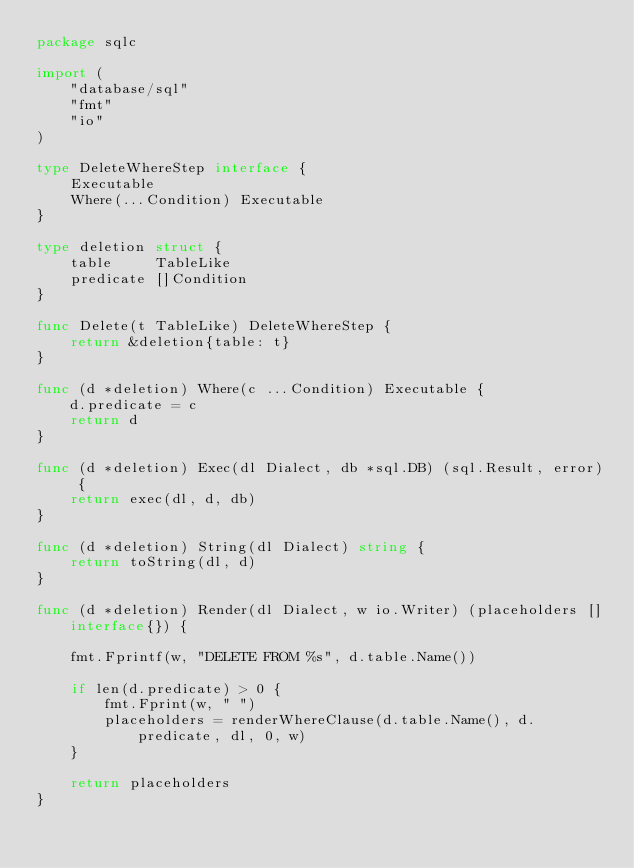<code> <loc_0><loc_0><loc_500><loc_500><_Go_>package sqlc

import (
	"database/sql"
	"fmt"
	"io"
)

type DeleteWhereStep interface {
	Executable
	Where(...Condition) Executable
}

type deletion struct {
	table     TableLike
	predicate []Condition
}

func Delete(t TableLike) DeleteWhereStep {
	return &deletion{table: t}
}

func (d *deletion) Where(c ...Condition) Executable {
	d.predicate = c
	return d
}

func (d *deletion) Exec(dl Dialect, db *sql.DB) (sql.Result, error) {
	return exec(dl, d, db)
}

func (d *deletion) String(dl Dialect) string {
	return toString(dl, d)
}

func (d *deletion) Render(dl Dialect, w io.Writer) (placeholders []interface{}) {

	fmt.Fprintf(w, "DELETE FROM %s", d.table.Name())

	if len(d.predicate) > 0 {
		fmt.Fprint(w, " ")
		placeholders = renderWhereClause(d.table.Name(), d.predicate, dl, 0, w)
	}

	return placeholders
}
</code> 